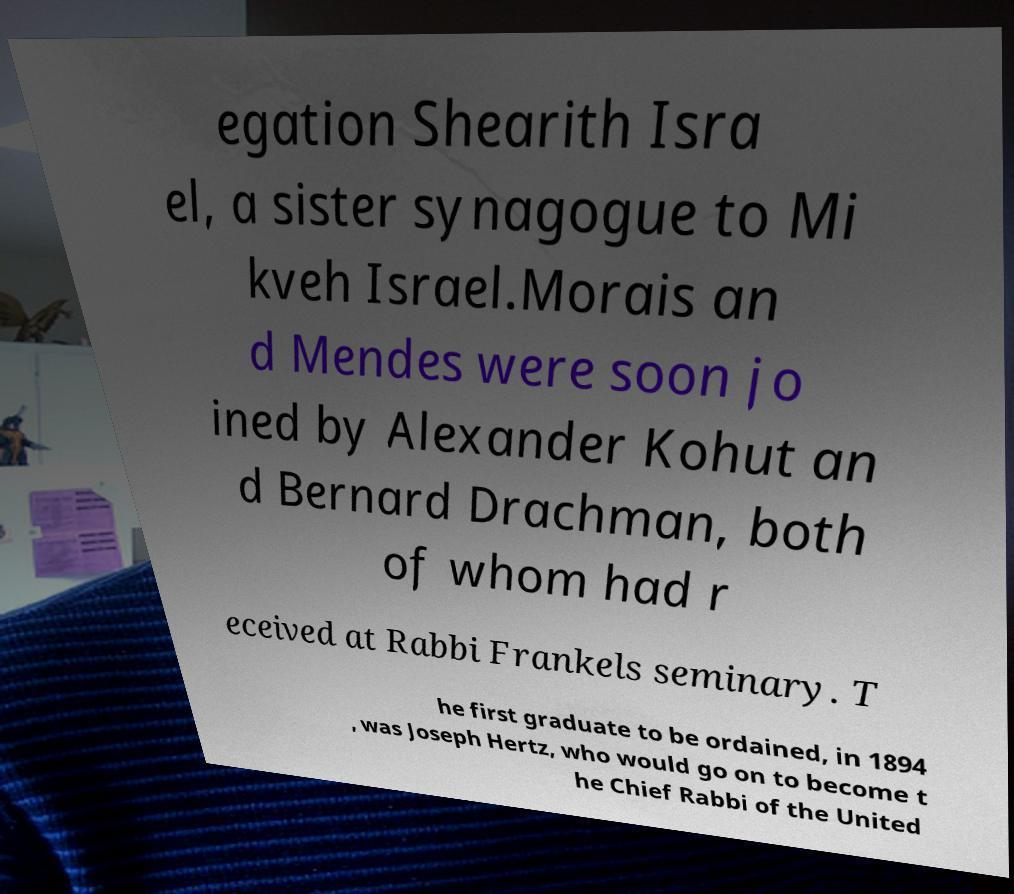For documentation purposes, I need the text within this image transcribed. Could you provide that? egation Shearith Isra el, a sister synagogue to Mi kveh Israel.Morais an d Mendes were soon jo ined by Alexander Kohut an d Bernard Drachman, both of whom had r eceived at Rabbi Frankels seminary. T he first graduate to be ordained, in 1894 , was Joseph Hertz, who would go on to become t he Chief Rabbi of the United 